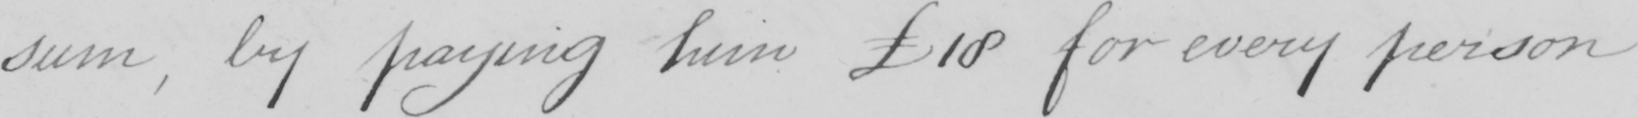What does this handwritten line say? sum , by paying him 18 for every person 